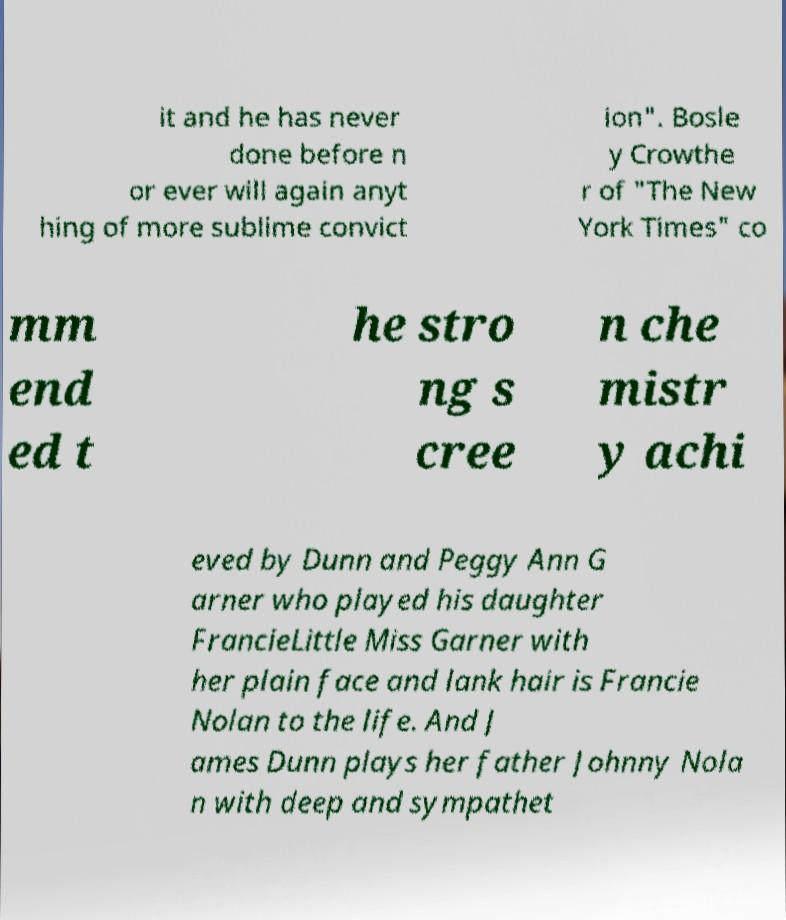What messages or text are displayed in this image? I need them in a readable, typed format. it and he has never done before n or ever will again anyt hing of more sublime convict ion". Bosle y Crowthe r of "The New York Times" co mm end ed t he stro ng s cree n che mistr y achi eved by Dunn and Peggy Ann G arner who played his daughter FrancieLittle Miss Garner with her plain face and lank hair is Francie Nolan to the life. And J ames Dunn plays her father Johnny Nola n with deep and sympathet 